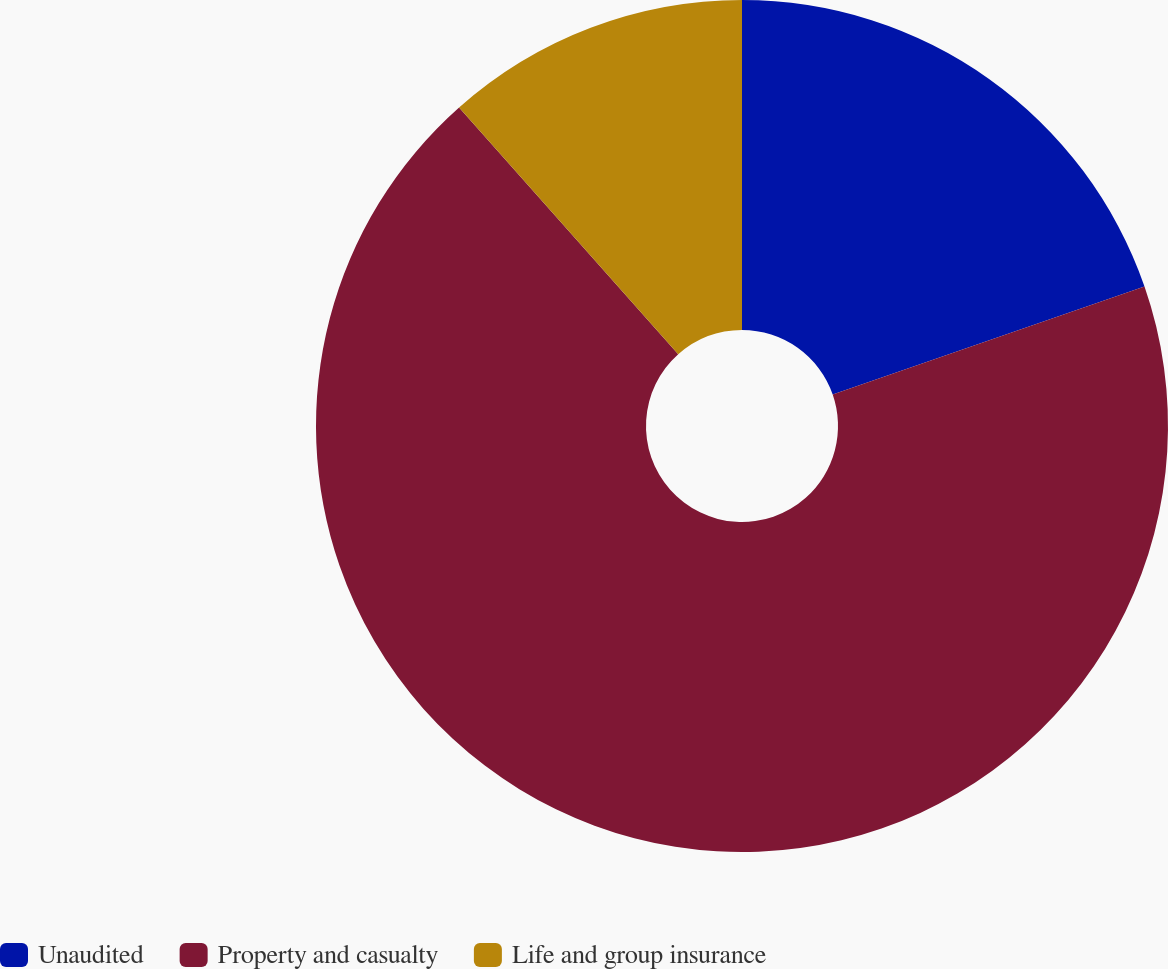Convert chart. <chart><loc_0><loc_0><loc_500><loc_500><pie_chart><fcel>Unaudited<fcel>Property and casualty<fcel>Life and group insurance<nl><fcel>19.69%<fcel>68.75%<fcel>11.56%<nl></chart> 